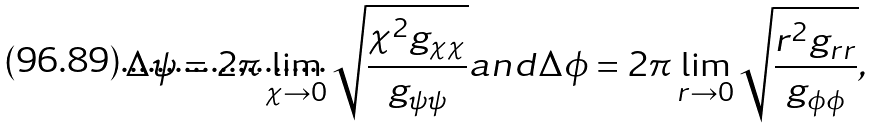Convert formula to latex. <formula><loc_0><loc_0><loc_500><loc_500>\Delta \psi = 2 \pi \lim _ { \chi \rightarrow 0 } \sqrt { \frac { \chi ^ { 2 } g _ { \chi \chi } } { g _ { \psi \psi } } } a n d \Delta \phi = 2 \pi \lim _ { r \rightarrow 0 } \sqrt { \frac { r ^ { 2 } g _ { r r } } { g _ { \phi \phi } } } ,</formula> 